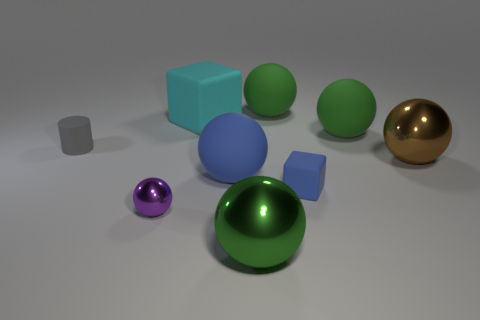Subtract all green balls. How many were subtracted if there are1green balls left? 2 Subtract all large brown shiny balls. How many balls are left? 5 Subtract all balls. How many objects are left? 3 Subtract all big brown metallic things. Subtract all matte spheres. How many objects are left? 5 Add 9 tiny metal things. How many tiny metal things are left? 10 Add 9 blue cubes. How many blue cubes exist? 10 Add 1 cyan rubber spheres. How many objects exist? 10 Subtract all brown balls. How many balls are left? 5 Subtract 1 gray cylinders. How many objects are left? 8 Subtract 1 blocks. How many blocks are left? 1 